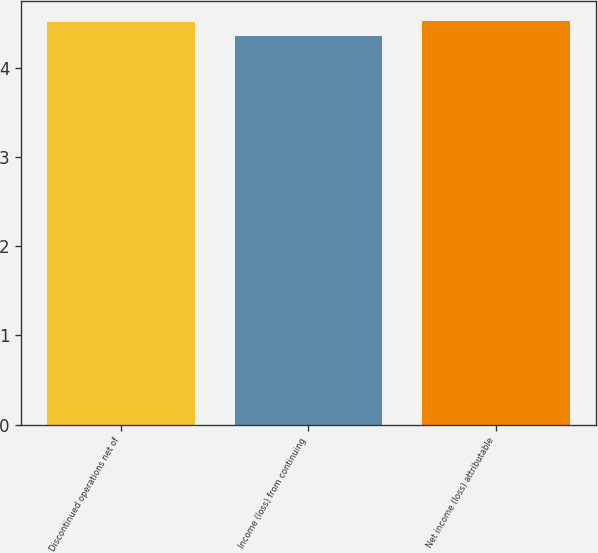<chart> <loc_0><loc_0><loc_500><loc_500><bar_chart><fcel>Discontinued operations net of<fcel>Income (loss) from continuing<fcel>Net income (loss) attributable<nl><fcel>4.51<fcel>4.36<fcel>4.52<nl></chart> 